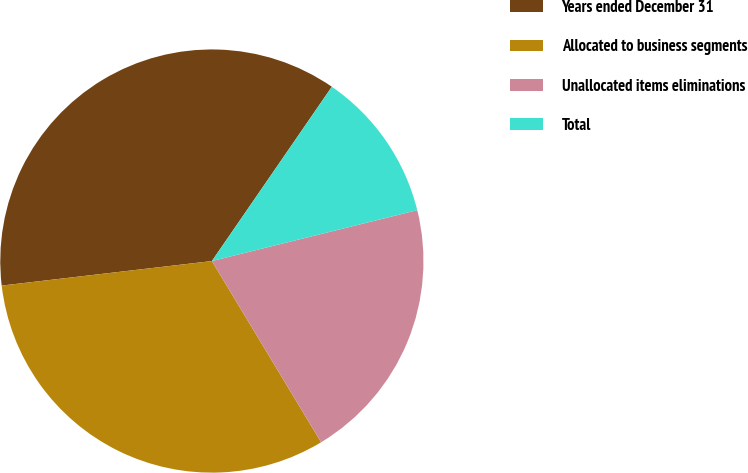<chart> <loc_0><loc_0><loc_500><loc_500><pie_chart><fcel>Years ended December 31<fcel>Allocated to business segments<fcel>Unallocated items eliminations<fcel>Total<nl><fcel>36.44%<fcel>31.78%<fcel>20.23%<fcel>11.54%<nl></chart> 